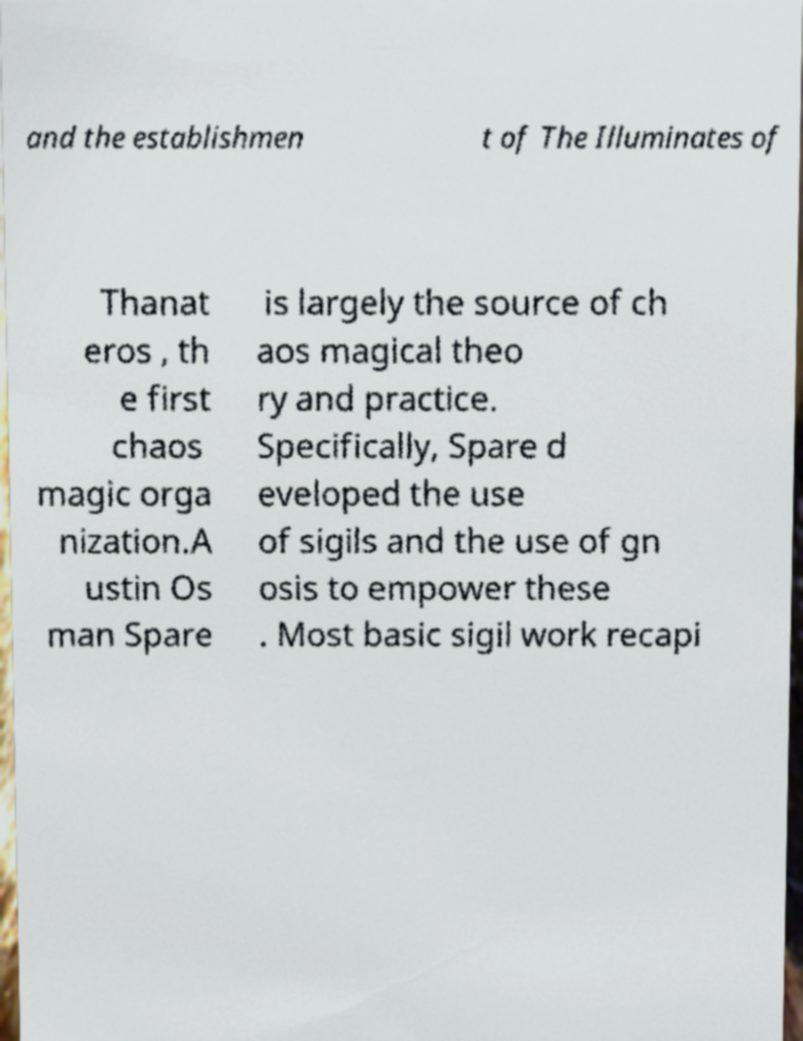Could you extract and type out the text from this image? and the establishmen t of The Illuminates of Thanat eros , th e first chaos magic orga nization.A ustin Os man Spare is largely the source of ch aos magical theo ry and practice. Specifically, Spare d eveloped the use of sigils and the use of gn osis to empower these . Most basic sigil work recapi 